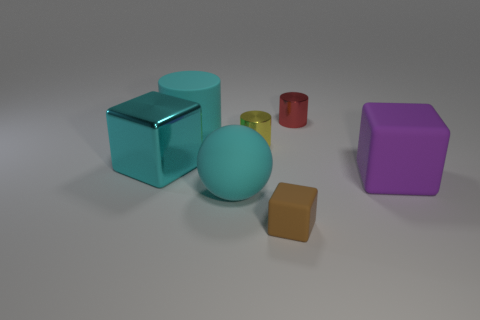Is the color of the big rubber cylinder the same as the large block left of the big rubber cylinder?
Provide a short and direct response. Yes. There is a shiny object behind the small thing that is to the left of the brown thing; are there any matte balls that are left of it?
Offer a very short reply. Yes. Are there fewer big cyan objects than red cubes?
Ensure brevity in your answer.  No. There is a metal object on the right side of the small rubber cube; does it have the same shape as the small yellow thing?
Your response must be concise. Yes. Is there a small shiny cylinder?
Your answer should be compact. Yes. There is a big object behind the metal object left of the tiny metallic cylinder in front of the small red metallic object; what is its color?
Offer a very short reply. Cyan. Are there the same number of cyan shiny blocks that are behind the matte cylinder and big cyan cylinders that are to the left of the brown cube?
Keep it short and to the point. No. What shape is the purple object that is the same size as the cyan metal thing?
Ensure brevity in your answer.  Cube. Are there any large cylinders that have the same color as the big matte ball?
Your answer should be compact. Yes. What shape is the small metal thing right of the brown matte thing?
Your answer should be very brief. Cylinder. 